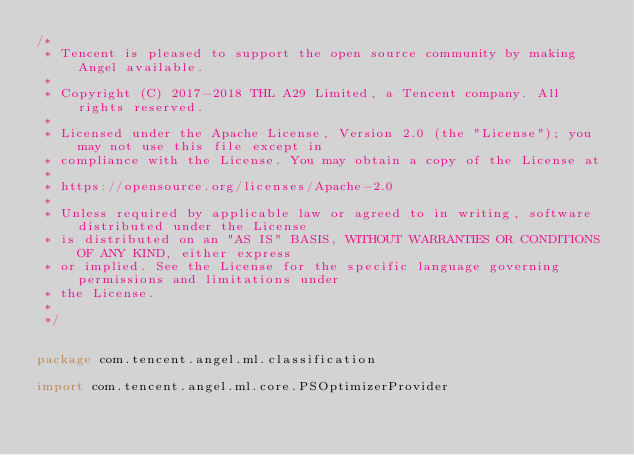<code> <loc_0><loc_0><loc_500><loc_500><_Scala_>/*
 * Tencent is pleased to support the open source community by making Angel available.
 *
 * Copyright (C) 2017-2018 THL A29 Limited, a Tencent company. All rights reserved.
 *
 * Licensed under the Apache License, Version 2.0 (the "License"); you may not use this file except in 
 * compliance with the License. You may obtain a copy of the License at
 *
 * https://opensource.org/licenses/Apache-2.0
 *
 * Unless required by applicable law or agreed to in writing, software distributed under the License
 * is distributed on an "AS IS" BASIS, WITHOUT WARRANTIES OR CONDITIONS OF ANY KIND, either express
 * or implied. See the License for the specific language governing permissions and limitations under
 * the License.
 *
 */


package com.tencent.angel.ml.classification

import com.tencent.angel.ml.core.PSOptimizerProvider</code> 